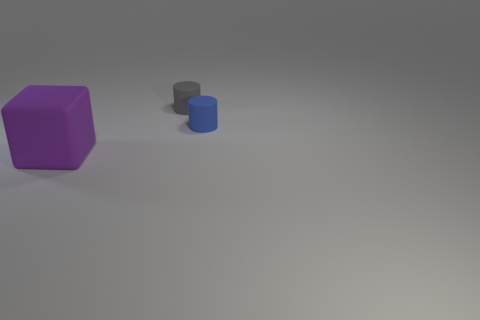Add 1 purple objects. How many objects exist? 4 Subtract all cylinders. How many objects are left? 1 Subtract 0 green cubes. How many objects are left? 3 Subtract all purple matte things. Subtract all tiny gray cylinders. How many objects are left? 1 Add 3 tiny gray matte objects. How many tiny gray matte objects are left? 4 Add 2 tiny purple rubber spheres. How many tiny purple rubber spheres exist? 2 